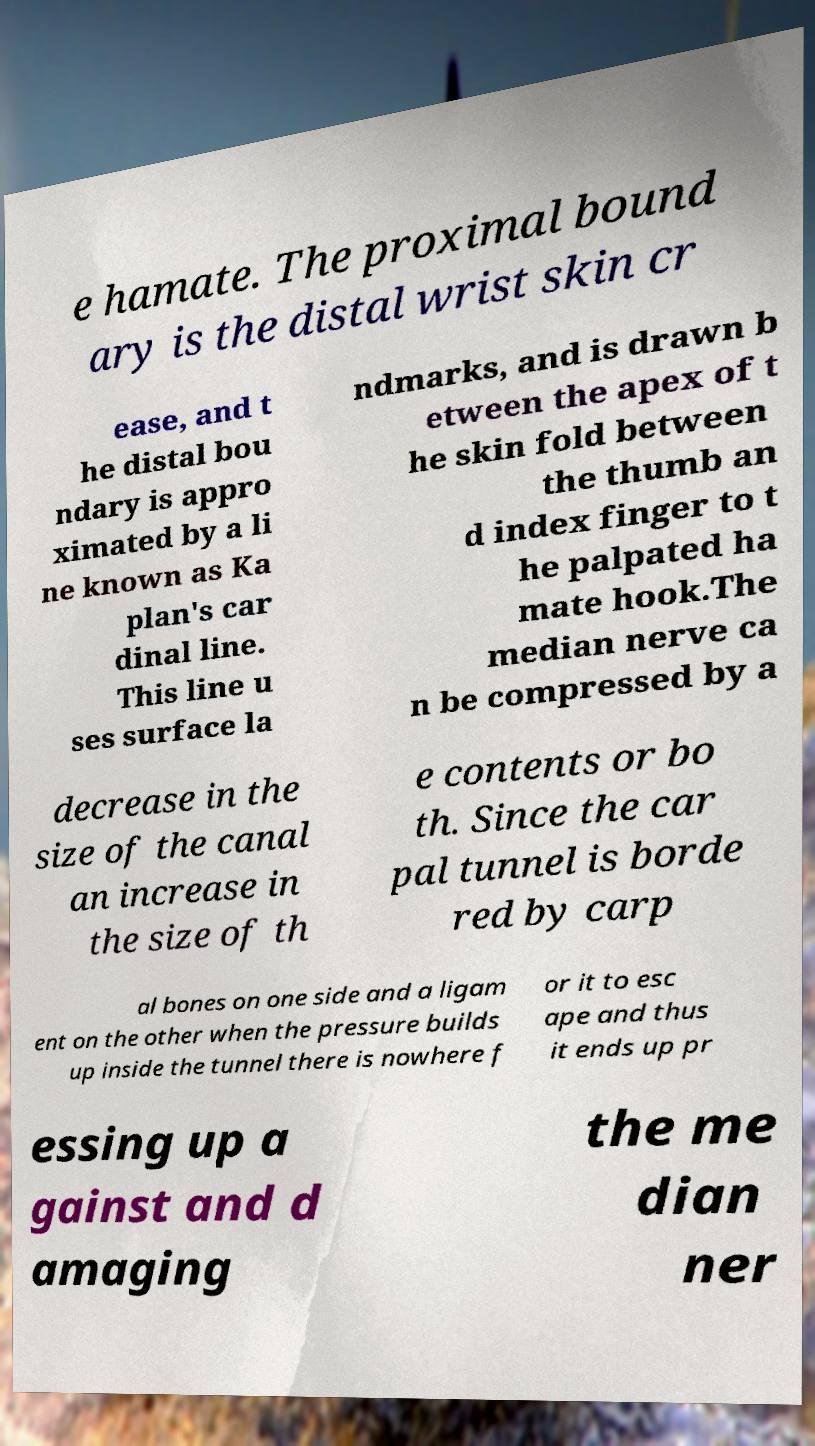Can you read and provide the text displayed in the image?This photo seems to have some interesting text. Can you extract and type it out for me? e hamate. The proximal bound ary is the distal wrist skin cr ease, and t he distal bou ndary is appro ximated by a li ne known as Ka plan's car dinal line. This line u ses surface la ndmarks, and is drawn b etween the apex of t he skin fold between the thumb an d index finger to t he palpated ha mate hook.The median nerve ca n be compressed by a decrease in the size of the canal an increase in the size of th e contents or bo th. Since the car pal tunnel is borde red by carp al bones on one side and a ligam ent on the other when the pressure builds up inside the tunnel there is nowhere f or it to esc ape and thus it ends up pr essing up a gainst and d amaging the me dian ner 